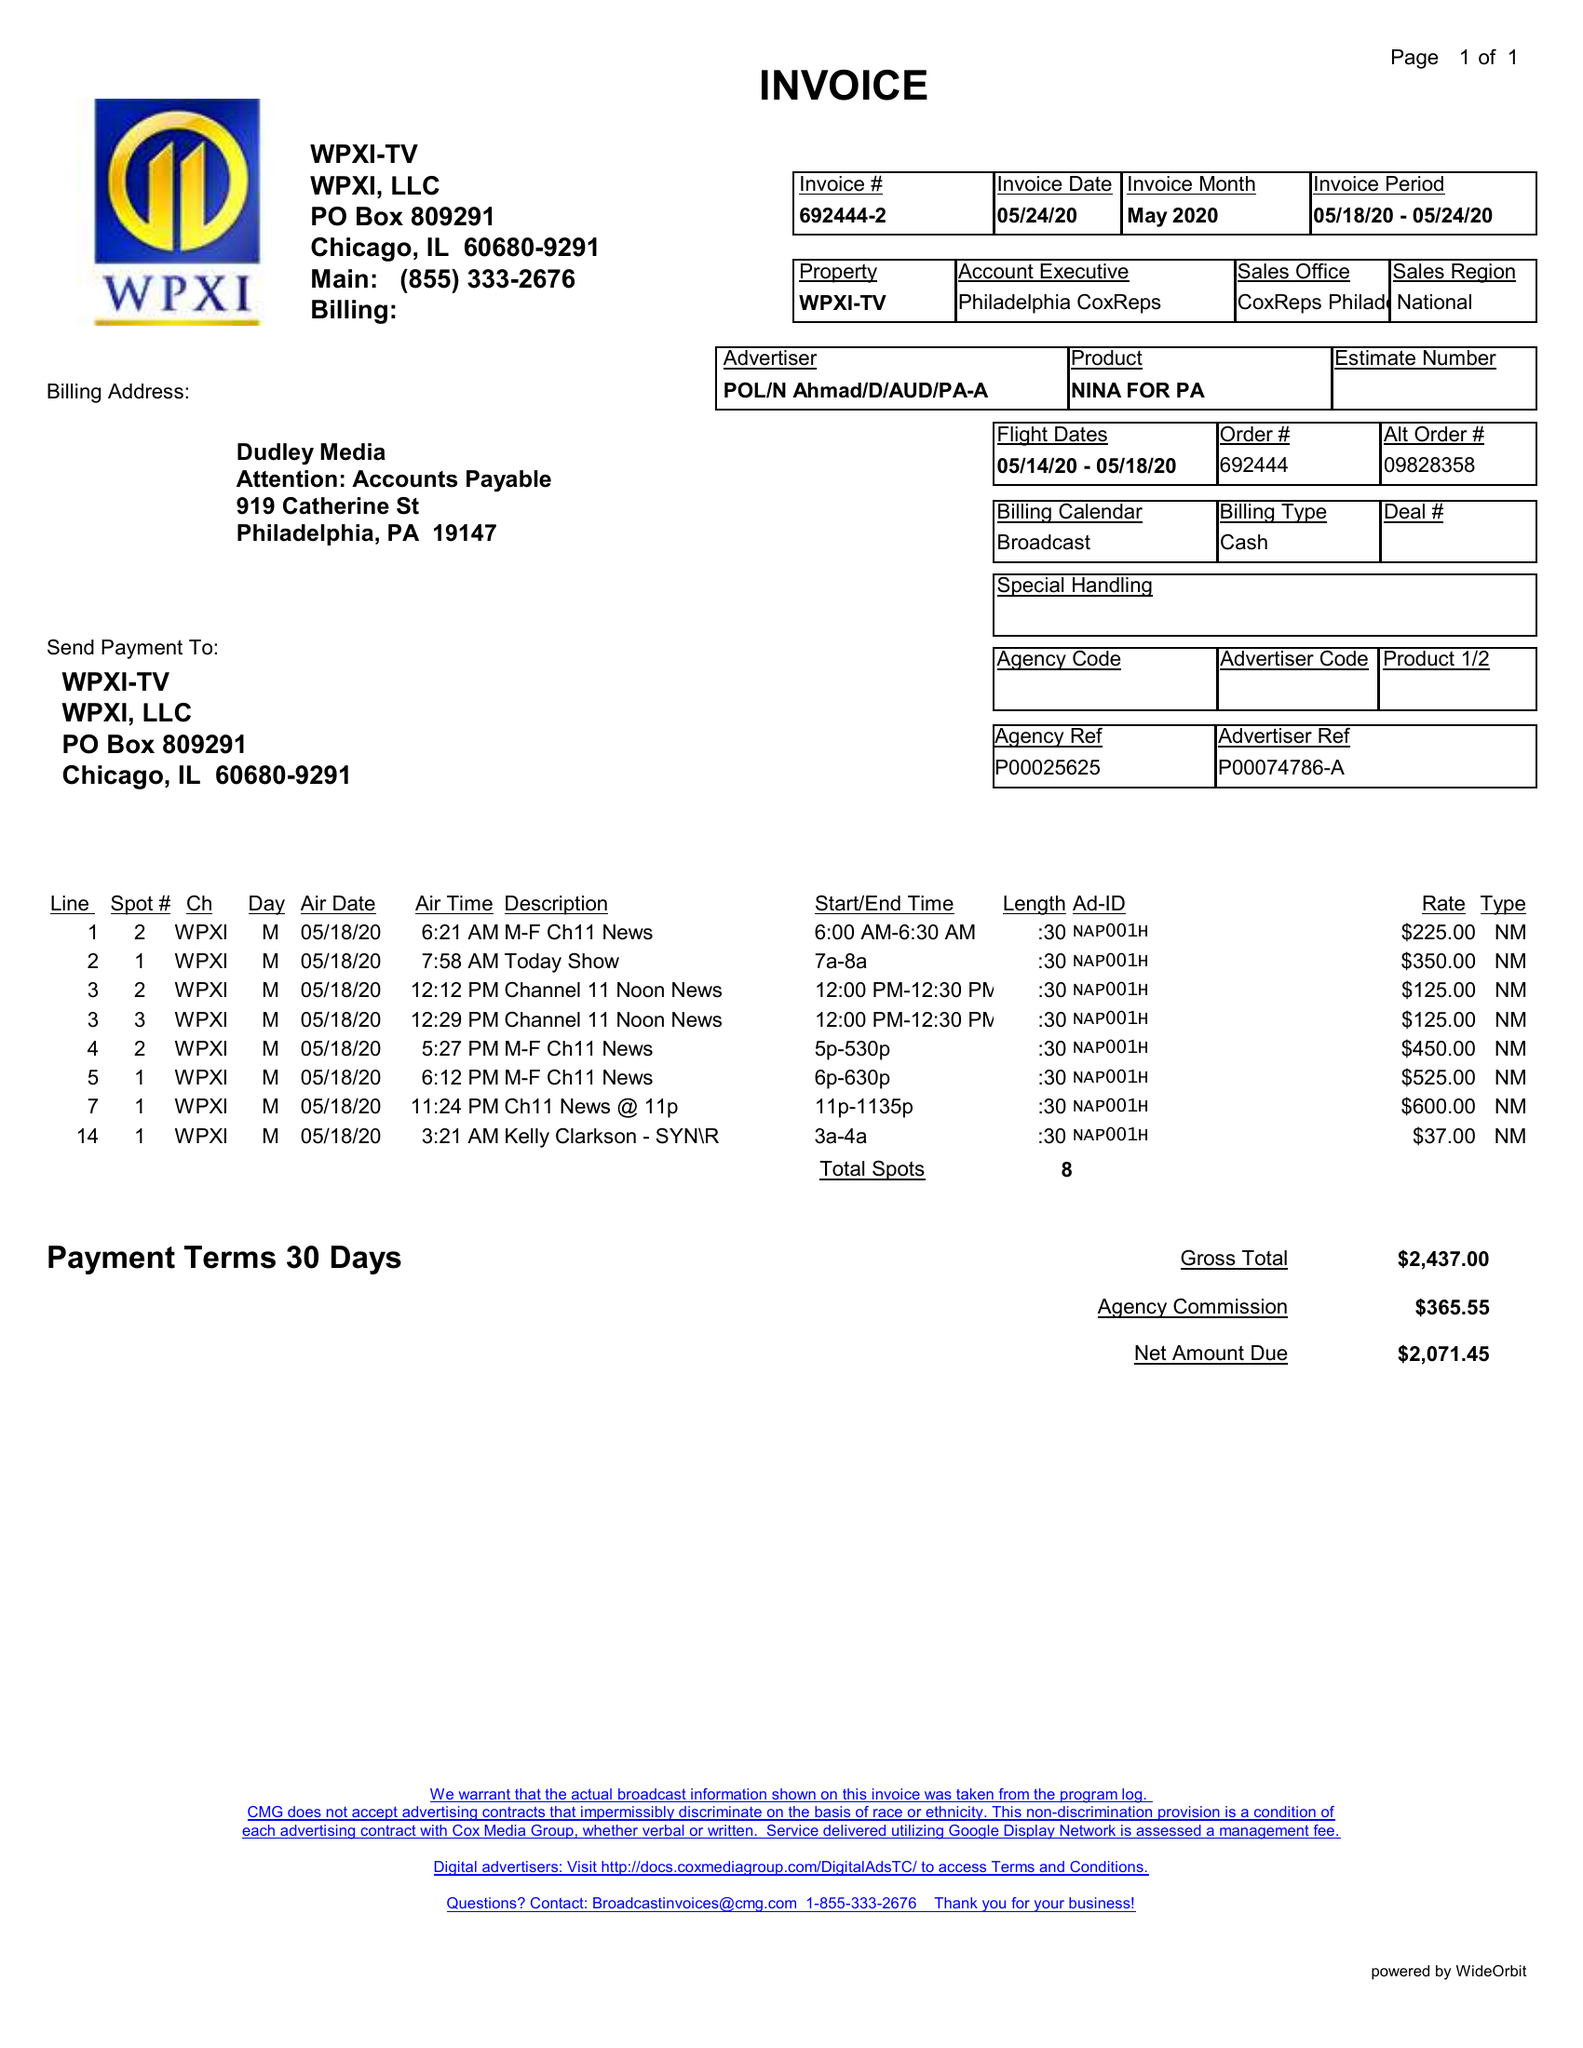What is the value for the gross_amount?
Answer the question using a single word or phrase. 2437.00 